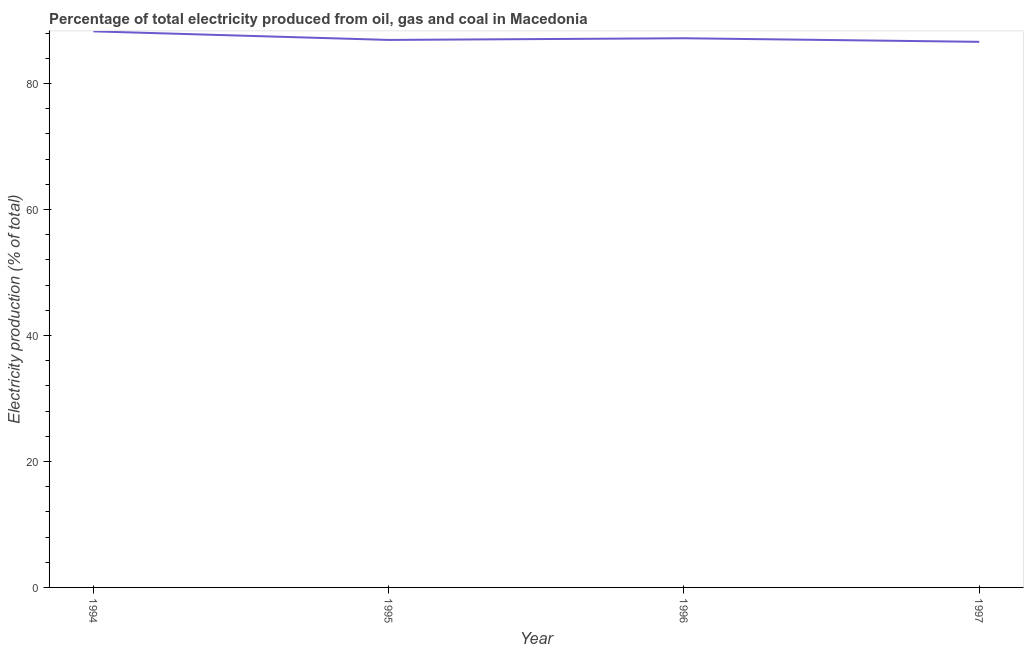What is the electricity production in 1997?
Your answer should be very brief. 86.63. Across all years, what is the maximum electricity production?
Offer a very short reply. 88.3. Across all years, what is the minimum electricity production?
Provide a succinct answer. 86.63. What is the sum of the electricity production?
Provide a succinct answer. 349.07. What is the difference between the electricity production in 1996 and 1997?
Ensure brevity in your answer.  0.57. What is the average electricity production per year?
Make the answer very short. 87.27. What is the median electricity production?
Keep it short and to the point. 87.07. Do a majority of the years between 1995 and 1996 (inclusive) have electricity production greater than 16 %?
Your answer should be very brief. Yes. What is the ratio of the electricity production in 1994 to that in 1996?
Offer a very short reply. 1.01. What is the difference between the highest and the second highest electricity production?
Your response must be concise. 1.1. What is the difference between the highest and the lowest electricity production?
Your answer should be compact. 1.66. In how many years, is the electricity production greater than the average electricity production taken over all years?
Your answer should be very brief. 1. How many lines are there?
Provide a succinct answer. 1. How many years are there in the graph?
Provide a short and direct response. 4. What is the difference between two consecutive major ticks on the Y-axis?
Your answer should be compact. 20. Are the values on the major ticks of Y-axis written in scientific E-notation?
Your response must be concise. No. Does the graph contain any zero values?
Your response must be concise. No. Does the graph contain grids?
Your answer should be very brief. No. What is the title of the graph?
Keep it short and to the point. Percentage of total electricity produced from oil, gas and coal in Macedonia. What is the label or title of the Y-axis?
Make the answer very short. Electricity production (% of total). What is the Electricity production (% of total) in 1994?
Give a very brief answer. 88.3. What is the Electricity production (% of total) of 1995?
Make the answer very short. 86.94. What is the Electricity production (% of total) of 1996?
Provide a short and direct response. 87.2. What is the Electricity production (% of total) in 1997?
Your answer should be very brief. 86.63. What is the difference between the Electricity production (% of total) in 1994 and 1995?
Your answer should be very brief. 1.36. What is the difference between the Electricity production (% of total) in 1994 and 1996?
Keep it short and to the point. 1.1. What is the difference between the Electricity production (% of total) in 1994 and 1997?
Make the answer very short. 1.66. What is the difference between the Electricity production (% of total) in 1995 and 1996?
Your answer should be very brief. -0.26. What is the difference between the Electricity production (% of total) in 1995 and 1997?
Give a very brief answer. 0.3. What is the difference between the Electricity production (% of total) in 1996 and 1997?
Offer a very short reply. 0.57. What is the ratio of the Electricity production (% of total) in 1994 to that in 1995?
Provide a succinct answer. 1.02. What is the ratio of the Electricity production (% of total) in 1994 to that in 1996?
Keep it short and to the point. 1.01. What is the ratio of the Electricity production (% of total) in 1995 to that in 1996?
Offer a very short reply. 1. 